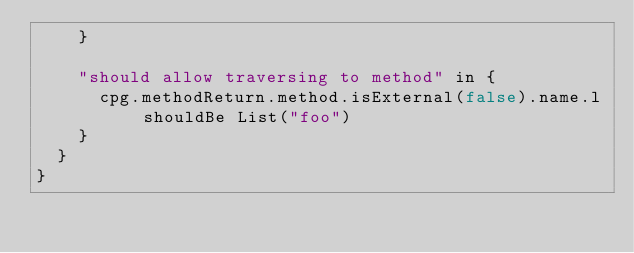Convert code to text. <code><loc_0><loc_0><loc_500><loc_500><_Scala_>    }

    "should allow traversing to method" in {
      cpg.methodReturn.method.isExternal(false).name.l shouldBe List("foo")
    }
  }
}
</code> 